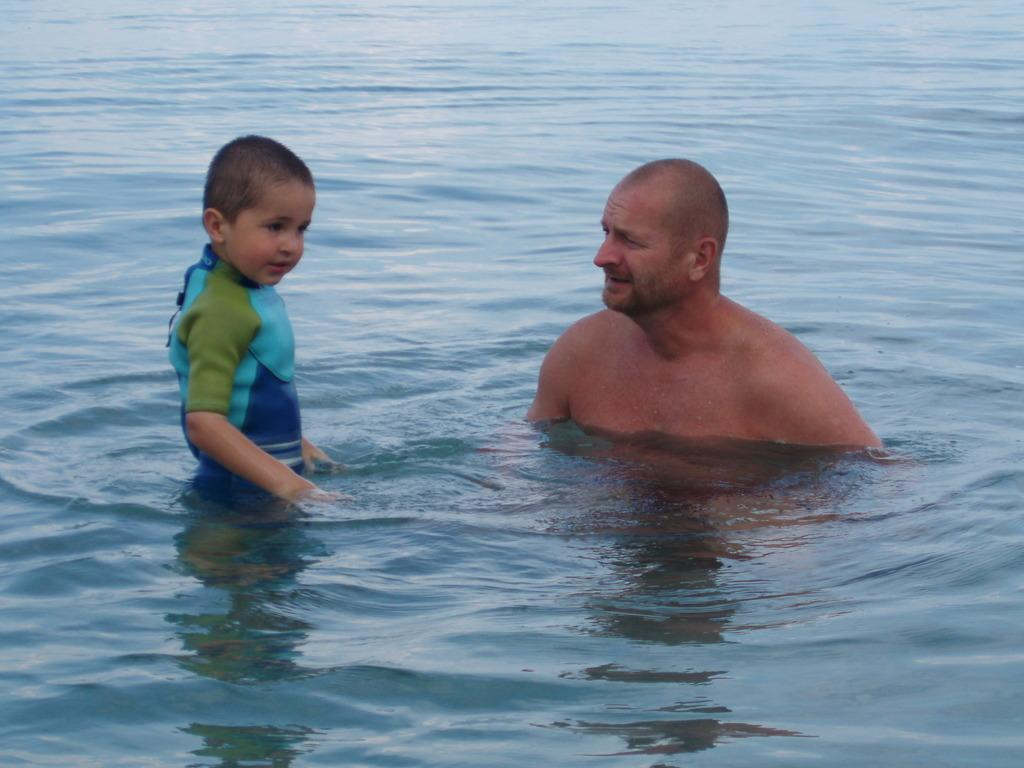How many people are in the image? There are two persons in the image. What is the location of the two persons in the image? The two persons are in the water. What type of mitten is the person wearing on their left hand in the image? There are no mittens present in the image; both persons are in the water without any visible clothing or accessories. 